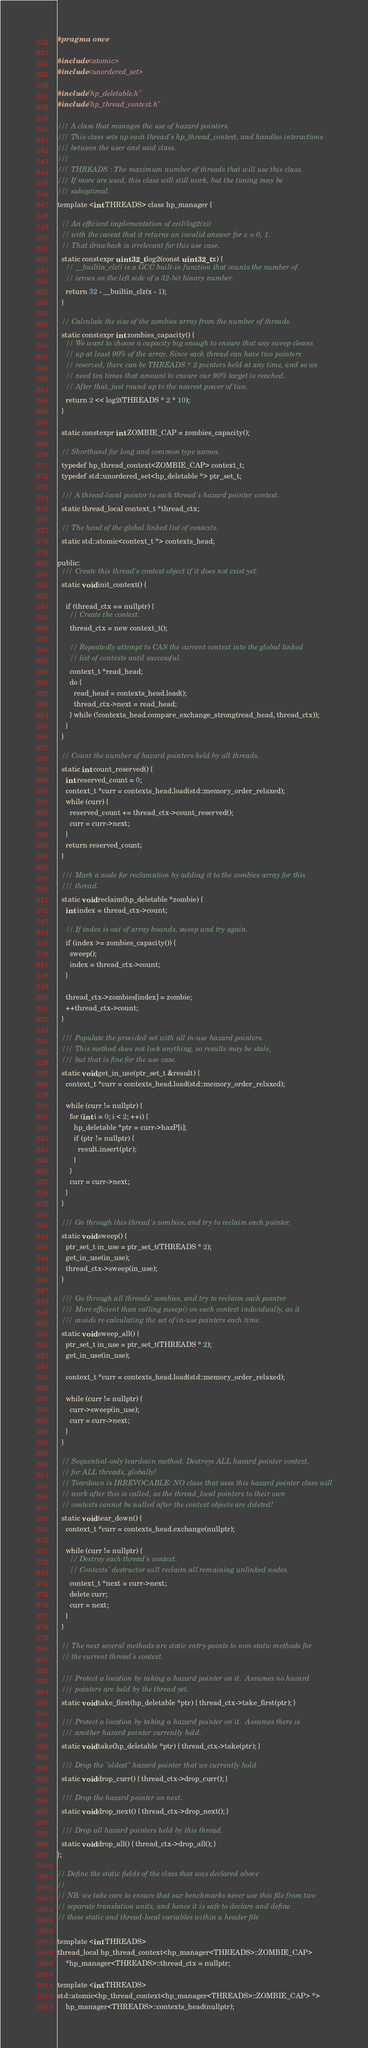<code> <loc_0><loc_0><loc_500><loc_500><_C_>#pragma once

#include <atomic>
#include <unordered_set>

#include "hp_deletable.h"
#include "hp_thread_context.h"

/// A class that manages the use of hazard pointers.
/// This class sets up each thread's hp_thread_context, and handles interactions
/// between the user and said class.
///
/// THREADS : The maximum number of threads that will use this class.
/// If more are used, this class will still work, but the tuning may be
/// suboptimal.
template <int THREADS> class hp_manager {

  // An efficient implementation of ceil(log2(x))
  // with the caveat that it returns an invalid answer for x = 0, 1.
  // That drawback is irrelevant for this use case.
  static constexpr uint32_t log2(const uint32_t x) {
    // __builtin_clz() is a GCC built-in function that counts the number of
    // zeroes on the left side of a 32-bit binary number.
    return 32 - __builtin_clz(x - 1);
  }

  // Calculate the size of the zombies array from the number of threads.
  static constexpr int zombies_capacity() {
    // We want to choose a capacity big enough to ensure that any sweep cleans
    // up at least 90% of the array. Since each thread can have two pointers
    // reserved, there can be THREADS * 2 pointers held at any time, and so we
    // need ten times that amount to ensure our 90% target is reached.
    // After that, just round up to the nearest power of two.
    return 2 << log2(THREADS * 2 * 10);
  }

  static constexpr int ZOMBIE_CAP = zombies_capacity();

  // Shorthand for long and common type names.
  typedef hp_thread_context<ZOMBIE_CAP> context_t;
  typedef std::unordered_set<hp_deletable *> ptr_set_t;

  /// A thread-local pointer to each thread's hazard pointer context.
  static thread_local context_t *thread_ctx;

  // The head of the global linked list of contexts.
  static std::atomic<context_t *> contexts_head;

public:
  /// Create this thread's context object if it does not exist yet.
  static void init_context() {

    if (thread_ctx == nullptr) {
      // Create the context.
      thread_ctx = new context_t();

      // Repeatedly attempt to CAS the current context into the global linked
      // list of contexts until successful.
      context_t *read_head;
      do {
        read_head = contexts_head.load();
        thread_ctx->next = read_head;
      } while (!contexts_head.compare_exchange_strong(read_head, thread_ctx));
    }
  }

  // Count the number of hazard pointers held by all threads.
  static int count_reserved() {
    int reserved_count = 0;
    context_t *curr = contexts_head.load(std::memory_order_relaxed);
    while (curr) {
      reserved_count += thread_ctx->count_reserved();
      curr = curr->next;
    }
    return reserved_count;
  }

  /// Mark a node for reclamation by adding it to the zombies array for this
  /// thread.
  static void reclaim(hp_deletable *zombie) {
    int index = thread_ctx->count;

    // If index is out of array bounds, sweep and try again.
    if (index >= zombies_capacity()) {
      sweep();
      index = thread_ctx->count;
    }

    thread_ctx->zombies[index] = zombie;
    ++thread_ctx->count;
  }

  /// Populate the provided set with all in-use hazard pointers.
  /// This method does not lock anything, so results may be stale,
  /// but that is fine for the use case.
  static void get_in_use(ptr_set_t &result) {
    context_t *curr = contexts_head.load(std::memory_order_relaxed);

    while (curr != nullptr) {
      for (int i = 0; i < 2; ++i) {
        hp_deletable *ptr = curr->hazP[i];
        if (ptr != nullptr) {
          result.insert(ptr);
        }
      }
      curr = curr->next;
    }
  }

  /// Go through this thread's zombies, and try to reclaim each pointer.
  static void sweep() {
    ptr_set_t in_use = ptr_set_t(THREADS * 2);
    get_in_use(in_use);
    thread_ctx->sweep(in_use);
  }

  /// Go through all threads' zombies, and try to reclaim each pointer.
  /// More efficient than calling sweep() on each context individually, as it
  /// avoids re-calculating the set of in-use pointers each time.
  static void sweep_all() {
    ptr_set_t in_use = ptr_set_t(THREADS * 2);
    get_in_use(in_use);

    context_t *curr = contexts_head.load(std::memory_order_relaxed);

    while (curr != nullptr) {
      curr->sweep(in_use);
      curr = curr->next;
    }
  }

  // Sequential-only teardown method. Destroys ALL hazard pointer context,
  // for ALL threads, globally!
  // Teardown is IRREVOCABLE: NO class that uses this hazard pointer class will
  // work after this is called, as the thread_local pointers to their own
  // contexts cannot be nulled after the context objects are deleted!
  static void tear_down() {
    context_t *curr = contexts_head.exchange(nullptr);

    while (curr != nullptr) {
      // Destroy each thread's context.
      // Contexts' destructor will reclaim all remaining unlinked nodes.
      context_t *next = curr->next;
      delete curr;
      curr = next;
    }
  }

  // The next several methods are static entry-points to non-static methods for
  // the current thread's context.

  /// Protect a location by taking a hazard pointer on it.  Assumes no hazard
  /// pointers are held by the thread yet.
  static void take_first(hp_deletable *ptr) { thread_ctx->take_first(ptr); }

  /// Protect a location by taking a hazard pointer on it.  Assumes there is
  /// another hazard pointer currently held.
  static void take(hp_deletable *ptr) { thread_ctx->take(ptr); }

  /// Drop the "oldest" hazard pointer that we currently hold
  static void drop_curr() { thread_ctx->drop_curr(); }

  /// Drop the hazard pointer on next.
  static void drop_next() { thread_ctx->drop_next(); }

  /// Drop all hazard pointers held by this thread.
  static void drop_all() { thread_ctx->drop_all(); }
};

// Define the static fields of the class that was declared above
//
// NB: we take care to ensure that our benchmarks never use this file from two
// separate translation units, and hence it is safe to declare and define
// these static and thread-local variables within a header file

template <int THREADS>
thread_local hp_thread_context<hp_manager<THREADS>::ZOMBIE_CAP>
    *hp_manager<THREADS>::thread_ctx = nullptr;

template <int THREADS>
std::atomic<hp_thread_context<hp_manager<THREADS>::ZOMBIE_CAP> *>
    hp_manager<THREADS>::contexts_head(nullptr);
</code> 